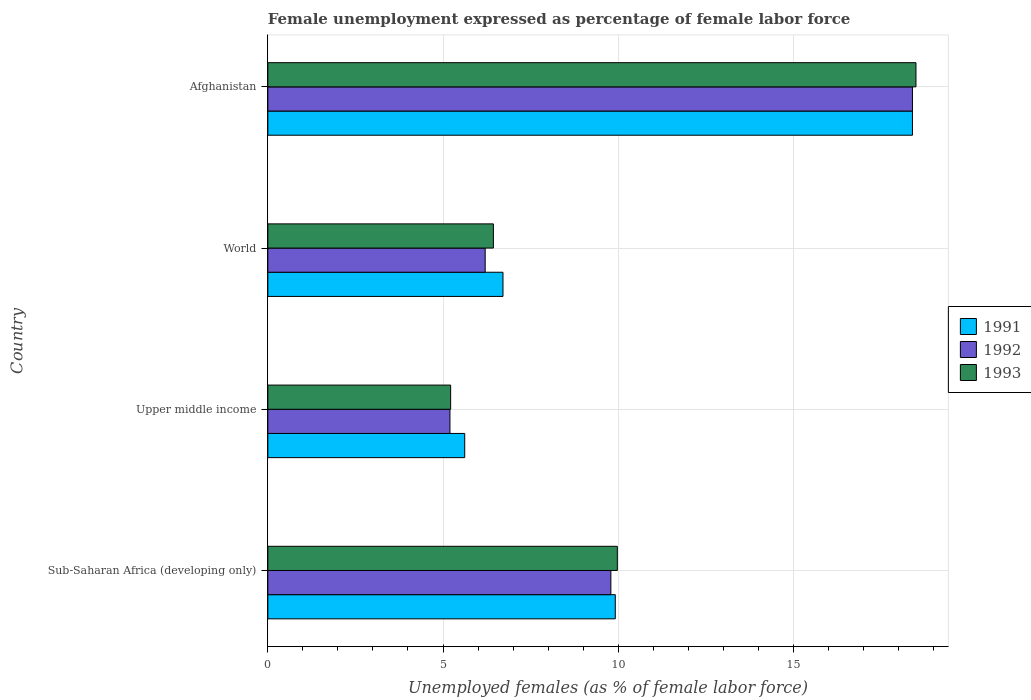How many different coloured bars are there?
Provide a succinct answer. 3. Are the number of bars per tick equal to the number of legend labels?
Keep it short and to the point. Yes. Are the number of bars on each tick of the Y-axis equal?
Offer a terse response. Yes. What is the unemployment in females in in 1992 in World?
Make the answer very short. 6.2. Across all countries, what is the maximum unemployment in females in in 1991?
Offer a very short reply. 18.4. Across all countries, what is the minimum unemployment in females in in 1992?
Offer a very short reply. 5.2. In which country was the unemployment in females in in 1991 maximum?
Provide a succinct answer. Afghanistan. In which country was the unemployment in females in in 1993 minimum?
Provide a succinct answer. Upper middle income. What is the total unemployment in females in in 1991 in the graph?
Ensure brevity in your answer.  40.65. What is the difference between the unemployment in females in in 1992 in Afghanistan and that in World?
Your response must be concise. 12.2. What is the difference between the unemployment in females in in 1993 in Upper middle income and the unemployment in females in in 1992 in Afghanistan?
Offer a very short reply. -13.18. What is the average unemployment in females in in 1993 per country?
Give a very brief answer. 10.03. What is the difference between the unemployment in females in in 1991 and unemployment in females in in 1992 in Sub-Saharan Africa (developing only)?
Make the answer very short. 0.13. In how many countries, is the unemployment in females in in 1991 greater than 8 %?
Offer a terse response. 2. What is the ratio of the unemployment in females in in 1991 in Sub-Saharan Africa (developing only) to that in Upper middle income?
Provide a succinct answer. 1.76. Is the difference between the unemployment in females in in 1991 in Upper middle income and World greater than the difference between the unemployment in females in in 1992 in Upper middle income and World?
Your answer should be very brief. No. What is the difference between the highest and the second highest unemployment in females in in 1993?
Provide a short and direct response. 8.52. What is the difference between the highest and the lowest unemployment in females in in 1992?
Provide a short and direct response. 13.2. Is it the case that in every country, the sum of the unemployment in females in in 1993 and unemployment in females in in 1991 is greater than the unemployment in females in in 1992?
Provide a succinct answer. Yes. How many bars are there?
Give a very brief answer. 12. Are all the bars in the graph horizontal?
Your answer should be compact. Yes. How many countries are there in the graph?
Ensure brevity in your answer.  4. What is the difference between two consecutive major ticks on the X-axis?
Ensure brevity in your answer.  5. Are the values on the major ticks of X-axis written in scientific E-notation?
Ensure brevity in your answer.  No. Does the graph contain any zero values?
Ensure brevity in your answer.  No. How many legend labels are there?
Your answer should be compact. 3. How are the legend labels stacked?
Your answer should be very brief. Vertical. What is the title of the graph?
Ensure brevity in your answer.  Female unemployment expressed as percentage of female labor force. What is the label or title of the X-axis?
Offer a very short reply. Unemployed females (as % of female labor force). What is the Unemployed females (as % of female labor force) of 1991 in Sub-Saharan Africa (developing only)?
Keep it short and to the point. 9.92. What is the Unemployed females (as % of female labor force) of 1992 in Sub-Saharan Africa (developing only)?
Keep it short and to the point. 9.79. What is the Unemployed females (as % of female labor force) of 1993 in Sub-Saharan Africa (developing only)?
Give a very brief answer. 9.98. What is the Unemployed females (as % of female labor force) in 1991 in Upper middle income?
Offer a terse response. 5.62. What is the Unemployed females (as % of female labor force) in 1992 in Upper middle income?
Offer a very short reply. 5.2. What is the Unemployed females (as % of female labor force) of 1993 in Upper middle income?
Offer a terse response. 5.22. What is the Unemployed females (as % of female labor force) of 1991 in World?
Keep it short and to the point. 6.71. What is the Unemployed females (as % of female labor force) in 1992 in World?
Provide a short and direct response. 6.2. What is the Unemployed females (as % of female labor force) of 1993 in World?
Your response must be concise. 6.44. What is the Unemployed females (as % of female labor force) of 1991 in Afghanistan?
Your answer should be compact. 18.4. What is the Unemployed females (as % of female labor force) in 1992 in Afghanistan?
Your response must be concise. 18.4. Across all countries, what is the maximum Unemployed females (as % of female labor force) in 1991?
Provide a short and direct response. 18.4. Across all countries, what is the maximum Unemployed females (as % of female labor force) in 1992?
Offer a very short reply. 18.4. Across all countries, what is the maximum Unemployed females (as % of female labor force) in 1993?
Provide a short and direct response. 18.5. Across all countries, what is the minimum Unemployed females (as % of female labor force) in 1991?
Offer a terse response. 5.62. Across all countries, what is the minimum Unemployed females (as % of female labor force) in 1992?
Provide a short and direct response. 5.2. Across all countries, what is the minimum Unemployed females (as % of female labor force) of 1993?
Provide a short and direct response. 5.22. What is the total Unemployed females (as % of female labor force) in 1991 in the graph?
Provide a succinct answer. 40.65. What is the total Unemployed females (as % of female labor force) in 1992 in the graph?
Your answer should be very brief. 39.59. What is the total Unemployed females (as % of female labor force) in 1993 in the graph?
Make the answer very short. 40.13. What is the difference between the Unemployed females (as % of female labor force) in 1991 in Sub-Saharan Africa (developing only) and that in Upper middle income?
Your answer should be compact. 4.3. What is the difference between the Unemployed females (as % of female labor force) of 1992 in Sub-Saharan Africa (developing only) and that in Upper middle income?
Provide a succinct answer. 4.59. What is the difference between the Unemployed females (as % of female labor force) of 1993 in Sub-Saharan Africa (developing only) and that in Upper middle income?
Offer a very short reply. 4.76. What is the difference between the Unemployed females (as % of female labor force) of 1991 in Sub-Saharan Africa (developing only) and that in World?
Offer a terse response. 3.21. What is the difference between the Unemployed females (as % of female labor force) in 1992 in Sub-Saharan Africa (developing only) and that in World?
Your answer should be compact. 3.59. What is the difference between the Unemployed females (as % of female labor force) in 1993 in Sub-Saharan Africa (developing only) and that in World?
Offer a very short reply. 3.54. What is the difference between the Unemployed females (as % of female labor force) in 1991 in Sub-Saharan Africa (developing only) and that in Afghanistan?
Your response must be concise. -8.48. What is the difference between the Unemployed females (as % of female labor force) in 1992 in Sub-Saharan Africa (developing only) and that in Afghanistan?
Provide a succinct answer. -8.61. What is the difference between the Unemployed females (as % of female labor force) in 1993 in Sub-Saharan Africa (developing only) and that in Afghanistan?
Your response must be concise. -8.52. What is the difference between the Unemployed females (as % of female labor force) in 1991 in Upper middle income and that in World?
Provide a succinct answer. -1.09. What is the difference between the Unemployed females (as % of female labor force) in 1992 in Upper middle income and that in World?
Keep it short and to the point. -1.01. What is the difference between the Unemployed females (as % of female labor force) in 1993 in Upper middle income and that in World?
Your answer should be compact. -1.22. What is the difference between the Unemployed females (as % of female labor force) of 1991 in Upper middle income and that in Afghanistan?
Your answer should be compact. -12.78. What is the difference between the Unemployed females (as % of female labor force) in 1992 in Upper middle income and that in Afghanistan?
Offer a terse response. -13.2. What is the difference between the Unemployed females (as % of female labor force) in 1993 in Upper middle income and that in Afghanistan?
Your answer should be compact. -13.28. What is the difference between the Unemployed females (as % of female labor force) of 1991 in World and that in Afghanistan?
Give a very brief answer. -11.69. What is the difference between the Unemployed females (as % of female labor force) in 1992 in World and that in Afghanistan?
Provide a short and direct response. -12.2. What is the difference between the Unemployed females (as % of female labor force) of 1993 in World and that in Afghanistan?
Ensure brevity in your answer.  -12.06. What is the difference between the Unemployed females (as % of female labor force) of 1991 in Sub-Saharan Africa (developing only) and the Unemployed females (as % of female labor force) of 1992 in Upper middle income?
Your answer should be very brief. 4.72. What is the difference between the Unemployed females (as % of female labor force) in 1991 in Sub-Saharan Africa (developing only) and the Unemployed females (as % of female labor force) in 1993 in Upper middle income?
Provide a succinct answer. 4.7. What is the difference between the Unemployed females (as % of female labor force) in 1992 in Sub-Saharan Africa (developing only) and the Unemployed females (as % of female labor force) in 1993 in Upper middle income?
Offer a terse response. 4.57. What is the difference between the Unemployed females (as % of female labor force) in 1991 in Sub-Saharan Africa (developing only) and the Unemployed females (as % of female labor force) in 1992 in World?
Your response must be concise. 3.71. What is the difference between the Unemployed females (as % of female labor force) in 1991 in Sub-Saharan Africa (developing only) and the Unemployed females (as % of female labor force) in 1993 in World?
Provide a succinct answer. 3.48. What is the difference between the Unemployed females (as % of female labor force) in 1992 in Sub-Saharan Africa (developing only) and the Unemployed females (as % of female labor force) in 1993 in World?
Give a very brief answer. 3.35. What is the difference between the Unemployed females (as % of female labor force) of 1991 in Sub-Saharan Africa (developing only) and the Unemployed females (as % of female labor force) of 1992 in Afghanistan?
Make the answer very short. -8.48. What is the difference between the Unemployed females (as % of female labor force) of 1991 in Sub-Saharan Africa (developing only) and the Unemployed females (as % of female labor force) of 1993 in Afghanistan?
Your response must be concise. -8.58. What is the difference between the Unemployed females (as % of female labor force) in 1992 in Sub-Saharan Africa (developing only) and the Unemployed females (as % of female labor force) in 1993 in Afghanistan?
Your answer should be compact. -8.71. What is the difference between the Unemployed females (as % of female labor force) of 1991 in Upper middle income and the Unemployed females (as % of female labor force) of 1992 in World?
Ensure brevity in your answer.  -0.58. What is the difference between the Unemployed females (as % of female labor force) in 1991 in Upper middle income and the Unemployed females (as % of female labor force) in 1993 in World?
Your answer should be very brief. -0.82. What is the difference between the Unemployed females (as % of female labor force) of 1992 in Upper middle income and the Unemployed females (as % of female labor force) of 1993 in World?
Give a very brief answer. -1.24. What is the difference between the Unemployed females (as % of female labor force) in 1991 in Upper middle income and the Unemployed females (as % of female labor force) in 1992 in Afghanistan?
Your answer should be compact. -12.78. What is the difference between the Unemployed females (as % of female labor force) of 1991 in Upper middle income and the Unemployed females (as % of female labor force) of 1993 in Afghanistan?
Your answer should be compact. -12.88. What is the difference between the Unemployed females (as % of female labor force) in 1992 in Upper middle income and the Unemployed females (as % of female labor force) in 1993 in Afghanistan?
Your answer should be very brief. -13.3. What is the difference between the Unemployed females (as % of female labor force) of 1991 in World and the Unemployed females (as % of female labor force) of 1992 in Afghanistan?
Make the answer very short. -11.69. What is the difference between the Unemployed females (as % of female labor force) of 1991 in World and the Unemployed females (as % of female labor force) of 1993 in Afghanistan?
Give a very brief answer. -11.79. What is the difference between the Unemployed females (as % of female labor force) of 1992 in World and the Unemployed females (as % of female labor force) of 1993 in Afghanistan?
Provide a succinct answer. -12.3. What is the average Unemployed females (as % of female labor force) of 1991 per country?
Give a very brief answer. 10.16. What is the average Unemployed females (as % of female labor force) in 1992 per country?
Provide a succinct answer. 9.9. What is the average Unemployed females (as % of female labor force) of 1993 per country?
Offer a terse response. 10.03. What is the difference between the Unemployed females (as % of female labor force) in 1991 and Unemployed females (as % of female labor force) in 1992 in Sub-Saharan Africa (developing only)?
Keep it short and to the point. 0.13. What is the difference between the Unemployed females (as % of female labor force) of 1991 and Unemployed females (as % of female labor force) of 1993 in Sub-Saharan Africa (developing only)?
Your answer should be compact. -0.06. What is the difference between the Unemployed females (as % of female labor force) in 1992 and Unemployed females (as % of female labor force) in 1993 in Sub-Saharan Africa (developing only)?
Ensure brevity in your answer.  -0.18. What is the difference between the Unemployed females (as % of female labor force) of 1991 and Unemployed females (as % of female labor force) of 1992 in Upper middle income?
Give a very brief answer. 0.42. What is the difference between the Unemployed females (as % of female labor force) of 1991 and Unemployed females (as % of female labor force) of 1993 in Upper middle income?
Give a very brief answer. 0.4. What is the difference between the Unemployed females (as % of female labor force) of 1992 and Unemployed females (as % of female labor force) of 1993 in Upper middle income?
Your response must be concise. -0.02. What is the difference between the Unemployed females (as % of female labor force) of 1991 and Unemployed females (as % of female labor force) of 1992 in World?
Provide a succinct answer. 0.51. What is the difference between the Unemployed females (as % of female labor force) of 1991 and Unemployed females (as % of female labor force) of 1993 in World?
Ensure brevity in your answer.  0.27. What is the difference between the Unemployed females (as % of female labor force) of 1992 and Unemployed females (as % of female labor force) of 1993 in World?
Make the answer very short. -0.23. What is the difference between the Unemployed females (as % of female labor force) of 1991 and Unemployed females (as % of female labor force) of 1992 in Afghanistan?
Offer a terse response. 0. What is the difference between the Unemployed females (as % of female labor force) in 1992 and Unemployed females (as % of female labor force) in 1993 in Afghanistan?
Your answer should be compact. -0.1. What is the ratio of the Unemployed females (as % of female labor force) in 1991 in Sub-Saharan Africa (developing only) to that in Upper middle income?
Offer a very short reply. 1.76. What is the ratio of the Unemployed females (as % of female labor force) in 1992 in Sub-Saharan Africa (developing only) to that in Upper middle income?
Provide a succinct answer. 1.88. What is the ratio of the Unemployed females (as % of female labor force) in 1993 in Sub-Saharan Africa (developing only) to that in Upper middle income?
Provide a succinct answer. 1.91. What is the ratio of the Unemployed females (as % of female labor force) of 1991 in Sub-Saharan Africa (developing only) to that in World?
Your answer should be very brief. 1.48. What is the ratio of the Unemployed females (as % of female labor force) in 1992 in Sub-Saharan Africa (developing only) to that in World?
Offer a terse response. 1.58. What is the ratio of the Unemployed females (as % of female labor force) in 1993 in Sub-Saharan Africa (developing only) to that in World?
Your response must be concise. 1.55. What is the ratio of the Unemployed females (as % of female labor force) of 1991 in Sub-Saharan Africa (developing only) to that in Afghanistan?
Your answer should be very brief. 0.54. What is the ratio of the Unemployed females (as % of female labor force) in 1992 in Sub-Saharan Africa (developing only) to that in Afghanistan?
Keep it short and to the point. 0.53. What is the ratio of the Unemployed females (as % of female labor force) of 1993 in Sub-Saharan Africa (developing only) to that in Afghanistan?
Make the answer very short. 0.54. What is the ratio of the Unemployed females (as % of female labor force) of 1991 in Upper middle income to that in World?
Your answer should be compact. 0.84. What is the ratio of the Unemployed females (as % of female labor force) of 1992 in Upper middle income to that in World?
Your answer should be very brief. 0.84. What is the ratio of the Unemployed females (as % of female labor force) in 1993 in Upper middle income to that in World?
Keep it short and to the point. 0.81. What is the ratio of the Unemployed females (as % of female labor force) in 1991 in Upper middle income to that in Afghanistan?
Your answer should be compact. 0.31. What is the ratio of the Unemployed females (as % of female labor force) in 1992 in Upper middle income to that in Afghanistan?
Ensure brevity in your answer.  0.28. What is the ratio of the Unemployed females (as % of female labor force) of 1993 in Upper middle income to that in Afghanistan?
Your response must be concise. 0.28. What is the ratio of the Unemployed females (as % of female labor force) of 1991 in World to that in Afghanistan?
Provide a short and direct response. 0.36. What is the ratio of the Unemployed females (as % of female labor force) of 1992 in World to that in Afghanistan?
Give a very brief answer. 0.34. What is the ratio of the Unemployed females (as % of female labor force) in 1993 in World to that in Afghanistan?
Provide a short and direct response. 0.35. What is the difference between the highest and the second highest Unemployed females (as % of female labor force) of 1991?
Your answer should be very brief. 8.48. What is the difference between the highest and the second highest Unemployed females (as % of female labor force) in 1992?
Ensure brevity in your answer.  8.61. What is the difference between the highest and the second highest Unemployed females (as % of female labor force) of 1993?
Offer a very short reply. 8.52. What is the difference between the highest and the lowest Unemployed females (as % of female labor force) of 1991?
Offer a very short reply. 12.78. What is the difference between the highest and the lowest Unemployed females (as % of female labor force) of 1992?
Your response must be concise. 13.2. What is the difference between the highest and the lowest Unemployed females (as % of female labor force) of 1993?
Give a very brief answer. 13.28. 